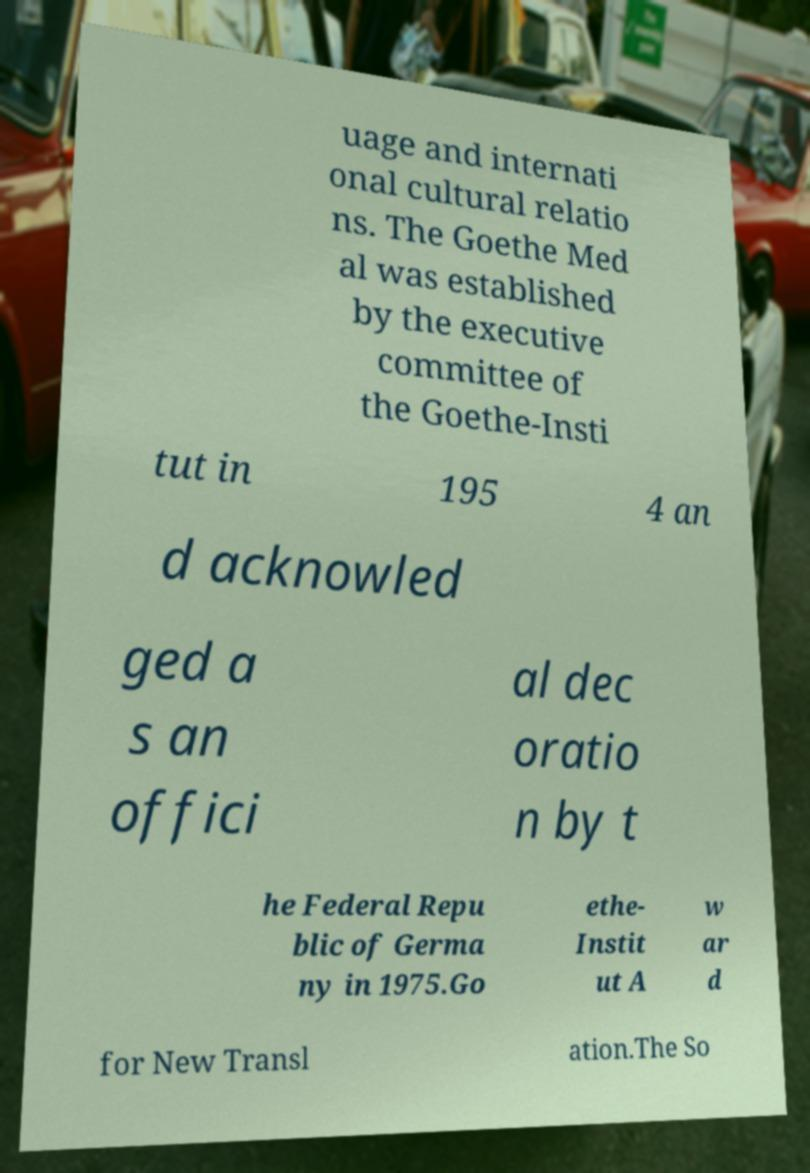Can you accurately transcribe the text from the provided image for me? uage and internati onal cultural relatio ns. The Goethe Med al was established by the executive committee of the Goethe-Insti tut in 195 4 an d acknowled ged a s an offici al dec oratio n by t he Federal Repu blic of Germa ny in 1975.Go ethe- Instit ut A w ar d for New Transl ation.The So 